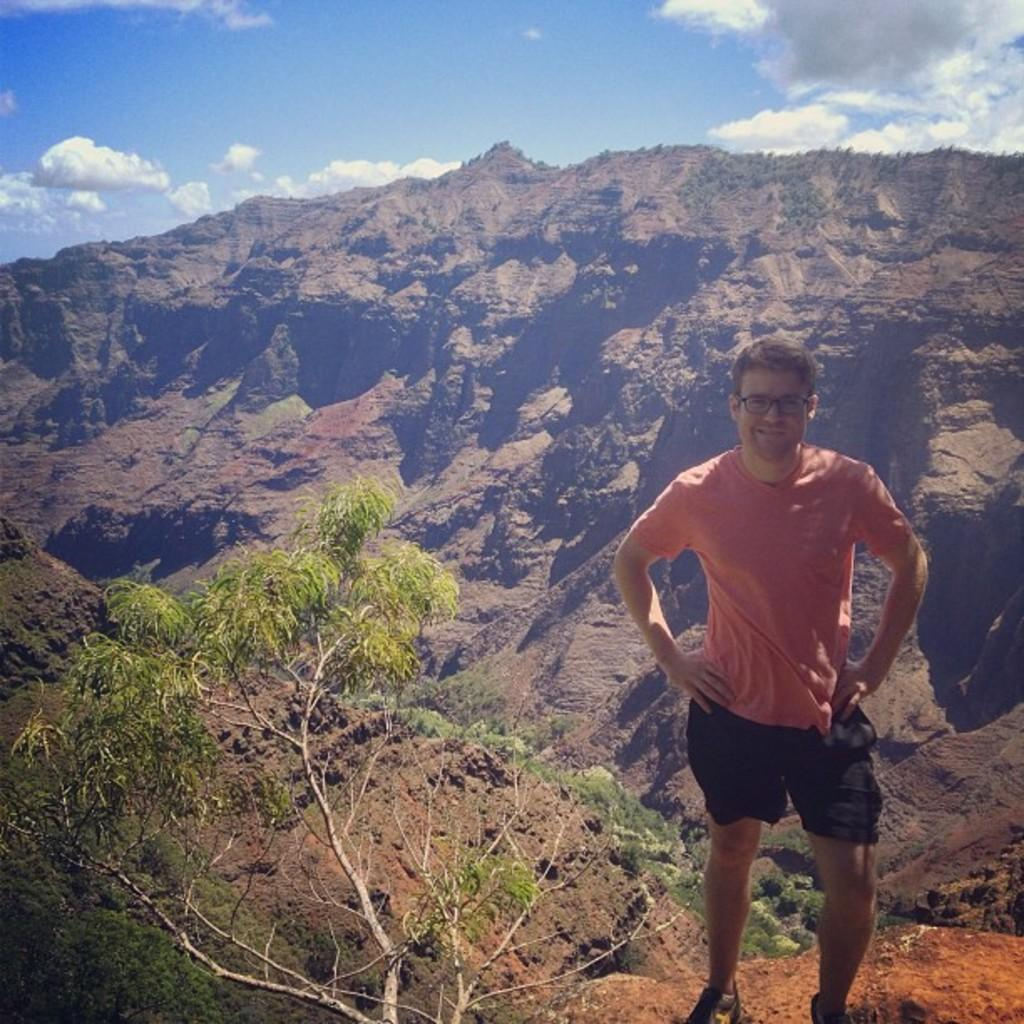What is the main subject of the image? There is a man standing in the image. What can be seen in the image besides the man? There is a tree in the image. What is visible in the background of the image? There are hills visible in the background of the image. How many dogs are sitting on the kettle in the image? There are no dogs or kettles present in the image. 